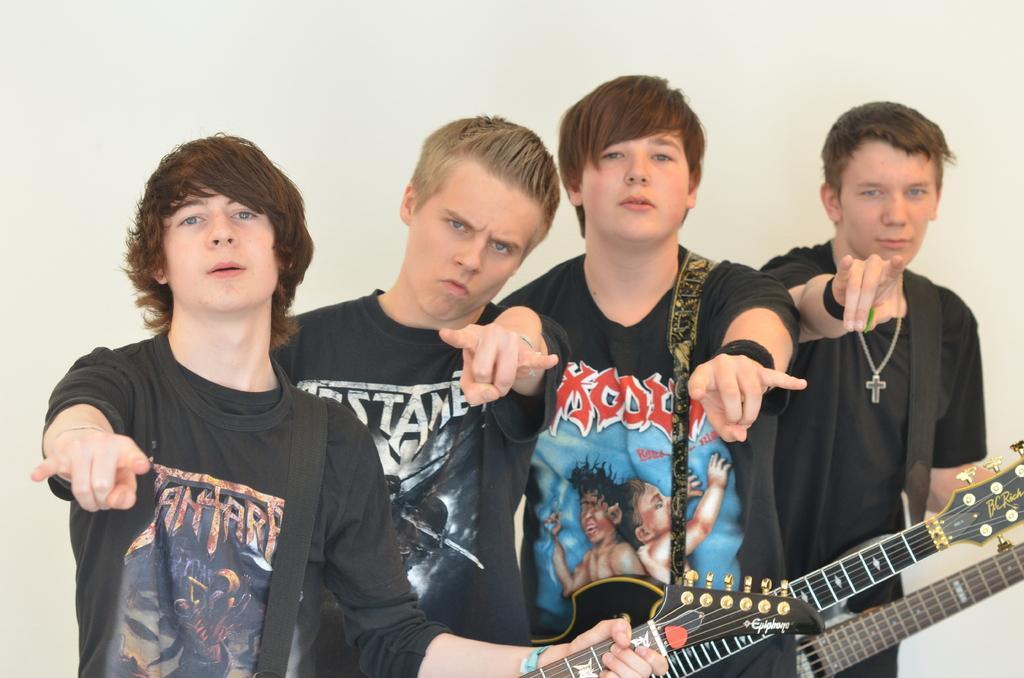Please provide a concise description of this image. There are four boys with the black t-shirt are standing. All they are playing guitars. 